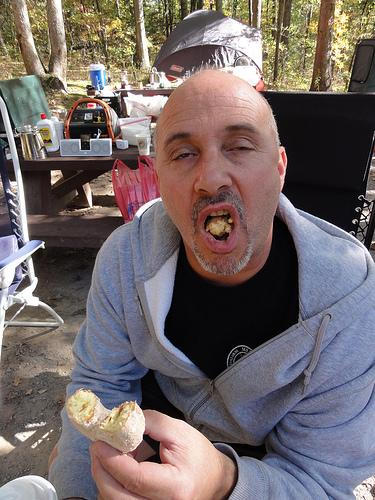Describe the clothing worn by the person in the image. The man is wearing a gray jacket, black tee shirt, and a white logo on his black shirt. Identify the food item being consumed by the person in the image. A bitten donut is being eaten by a man in the image. List three objects found on the wooden picnic table. Silver metal tea kettle, white plastic bottle with yellow label and red cap, and white and brown disposable coffee cup. What type of tent can be seen in the image? There is a gray camping tent in between trees. Which object is being held in the man's hand? The man is holding a partially eaten donut in his hand. Mention the color and shape of the bottle with a red cap. The bottle is white, and it has a cylindrical shape. How many trees are visible in the image? There are at least two distinct trees in the image, one with a double trunk on the left and another with a large tree trunk. What electronic device can be seen in the image? A music playing device, possibly an iPod speaker system, is present in the image. What type of chair is visible in the image? A white metal outdoor chair, possibly a lawn chair, is seen in the image. What is the man wearing in the image? gray jacket, black shirt, and a mustache Can you find a green bottle with a purple cap next to the tent? There is a white bottle with a red cap mentioned in the image but no green bottle with a purple cap. Is there a small child sitting at the wooden picnic table? The wooden picnic table is mentioned in the image, but there is no mention of a small child sitting at the table. Describe the object located at X:33 Y:111 in the image. white bottle with red cap What is the man holding in his hand? a partially eaten donut What type of outerwear is the man wearing? a gray hooded sweatshirt Describe the scene with the canvas covertent. A canvas covertent behind a man surrounded by trees. Is there a white donut with blue sprinkles in the man's hand? There is a partially eaten donut in the man's hand, but there is no mention of blue sprinkles, and the donut is described as having powdered sugar. What type of chair is located at X:0 Y:88? white metal outdoor chair Select the correct description of the man's shirt: (a) white shirt (b) red shirt (c) yellow shirt (d) black shirt (d) black shirt List all objects found on the table. wooden picnic table, silver metal tea kettle, white plastic bottle with yellow label and red cap, white and brown disposable coffee cup, red plastic grocery bag Are there any animals or birds present around the gray tent? There is a gray tent surrounded by trees in the image but no mention of any animals or birds present around it. Describe the location of the gray tent in relation to the trees. The gray tent is in between trees. Describe the man's appearance in the image. a man with a mustache wearing a gray jacket, eating a donut Is there a camping scene present in the image? Yes, there is a gray camping tent in the image. Does the man have a beard and glasses in the image? The man is described as having a bald head, a mustache, and with his mouth open, but there is no mention of a beard or glasses. What object is at X:206 Y:215? a piece of donut in mouth What type of beverage container is at X:134 Y:132? white and brown disposable coffee cup Describe the appearance of the donut in the image. white powdered sugar doughnut, partially eaten Identify the device located at X:75 Y:124. music playing device What type of activity is the man engaged in? The man is eating a donut. Can you spot a blue umbrella near the white metal outdoor chair? There is a white metal outdoor chair mentioned in the image, but there is no mention of a blue umbrella near it. Identify the object at X:255 Y:89 in the image. a tree with double trunk on left Which objects are related to a man with food in his mouth? a man with food in his mouth, a bitten donut, a man eating a donut Is there any object in the image that can be associated with music? Yes, there is a white speakers and a music playing device. 